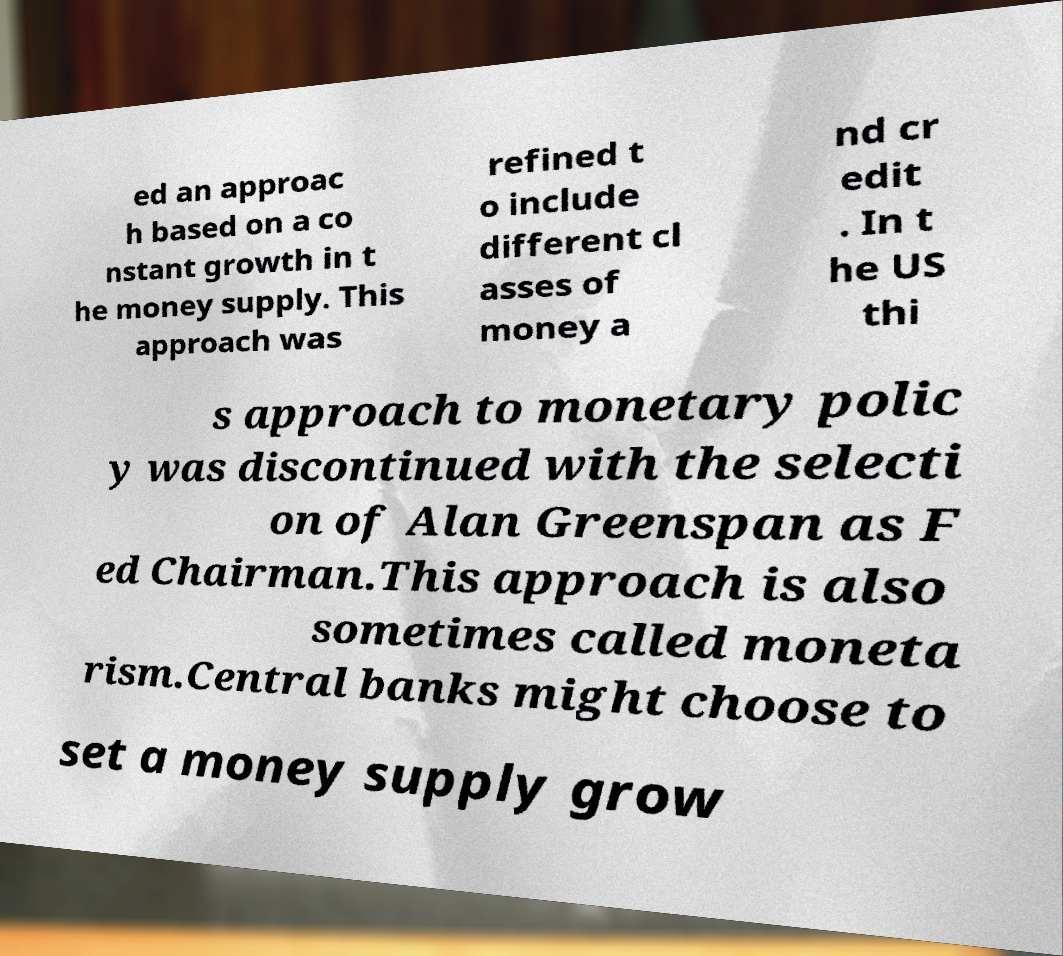There's text embedded in this image that I need extracted. Can you transcribe it verbatim? ed an approac h based on a co nstant growth in t he money supply. This approach was refined t o include different cl asses of money a nd cr edit . In t he US thi s approach to monetary polic y was discontinued with the selecti on of Alan Greenspan as F ed Chairman.This approach is also sometimes called moneta rism.Central banks might choose to set a money supply grow 